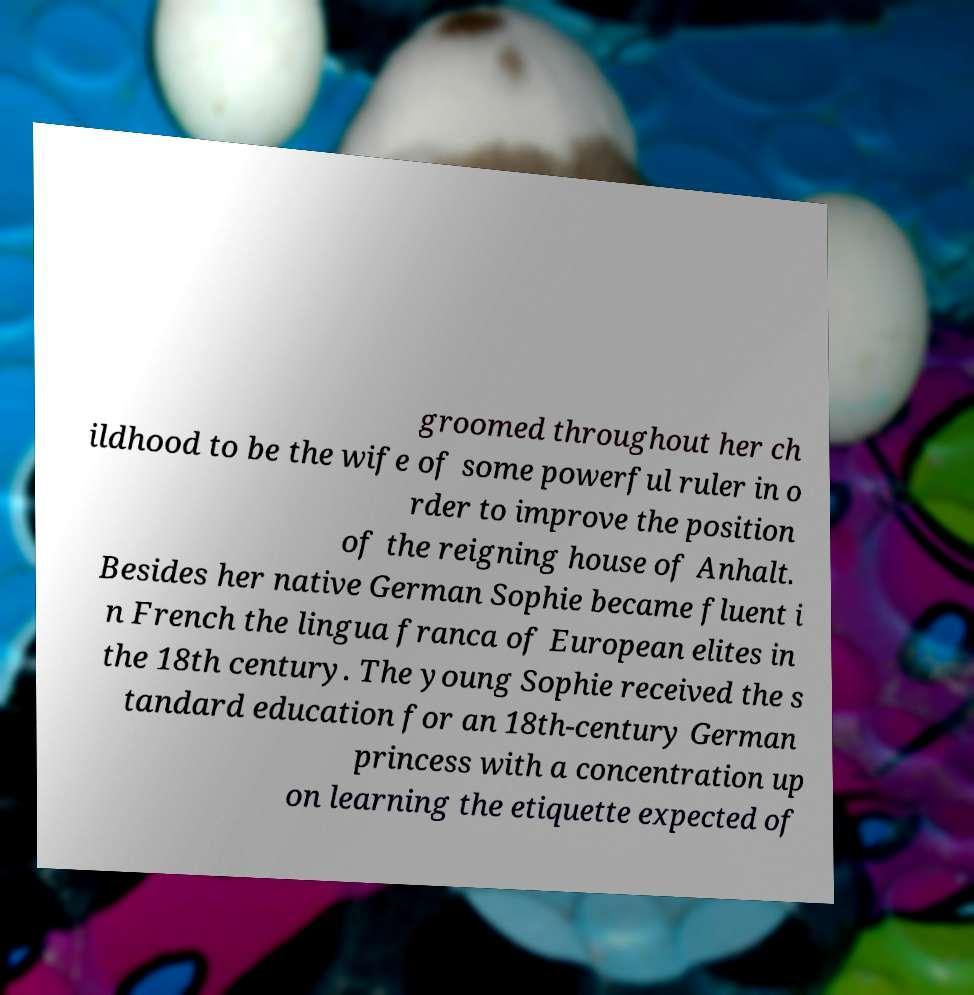Please identify and transcribe the text found in this image. groomed throughout her ch ildhood to be the wife of some powerful ruler in o rder to improve the position of the reigning house of Anhalt. Besides her native German Sophie became fluent i n French the lingua franca of European elites in the 18th century. The young Sophie received the s tandard education for an 18th-century German princess with a concentration up on learning the etiquette expected of 